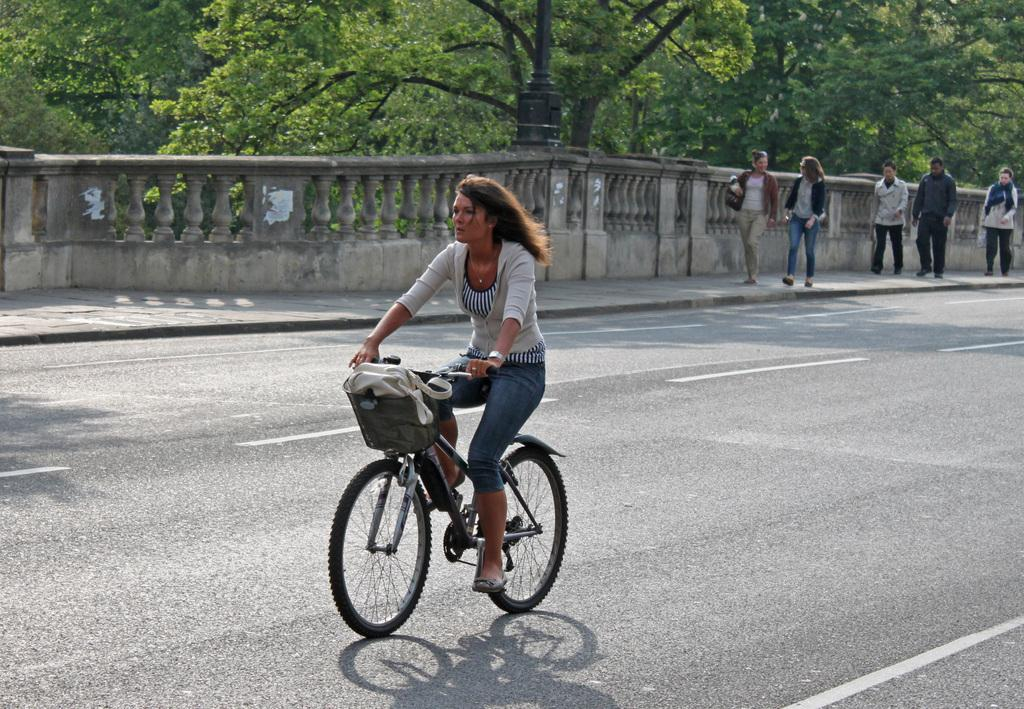What is the woman in the image doing? The woman is riding a bicycle in the image. Where is the woman riding the bicycle? The woman is on the road. What else can be seen happening on the road in the image? There are people walking on the side of the road. What can be seen in the background of the image? There are trees in the background of the image. What type of hammer is the woman using to ride the bicycle in the image? There is no hammer present in the image, and the woman is not using any tool to ride the bicycle. 